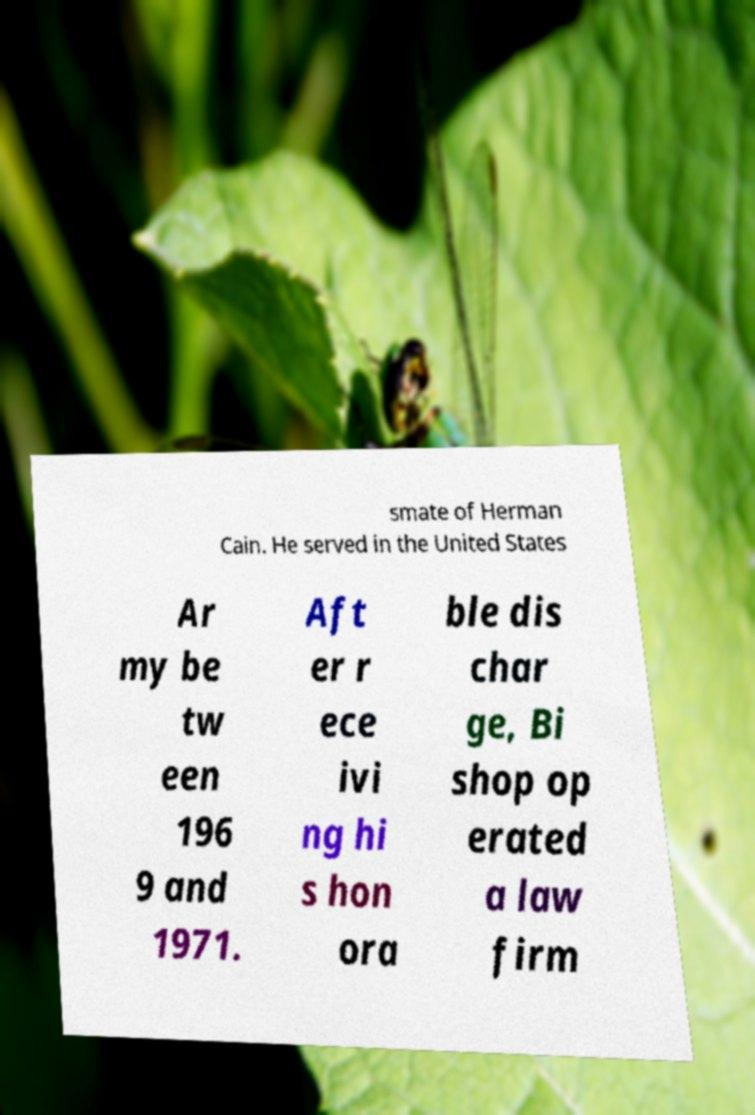Could you assist in decoding the text presented in this image and type it out clearly? smate of Herman Cain. He served in the United States Ar my be tw een 196 9 and 1971. Aft er r ece ivi ng hi s hon ora ble dis char ge, Bi shop op erated a law firm 